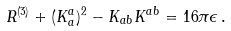<formula> <loc_0><loc_0><loc_500><loc_500>R ^ { ( 3 ) } + ( K _ { a } ^ { a } ) ^ { 2 } - K _ { a b } K ^ { a b } = 1 6 \pi \epsilon \, .</formula> 